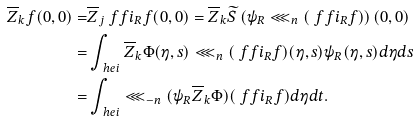<formula> <loc_0><loc_0><loc_500><loc_500>\overline { Z } _ { k } f ( 0 , 0 ) = & \overline { Z } _ { j } \ f f i _ { R } f ( 0 , 0 ) = \overline { Z } _ { k } \widetilde { S } \left ( \psi _ { R } \lll _ { n } ( \ f f i _ { R } f ) \right ) ( 0 , 0 ) \\ = & \int _ { \ h e i } \overline { Z } _ { k } \Phi ( \eta , s ) \lll _ { n } ( \ f f i _ { R } f ) ( \eta , s ) \psi _ { R } ( \eta , s ) d \eta d s \\ = & \int _ { \ h e i } \lll _ { - n } ( \psi _ { R } \overline { Z } _ { k } \Phi ) ( \ f f i _ { R } f ) d \eta d t .</formula> 